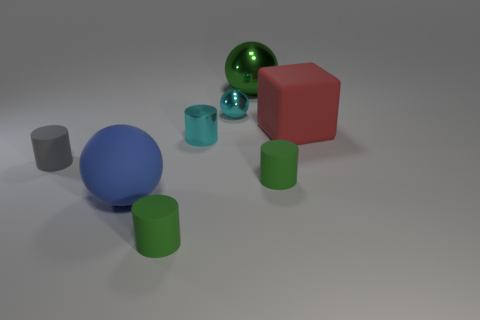What is the size of the metal object that is the same color as the metal cylinder?
Provide a short and direct response. Small. There is a matte cylinder that is to the left of the small thing that is in front of the blue rubber sphere; what color is it?
Make the answer very short. Gray. Are there any things of the same color as the tiny ball?
Give a very brief answer. Yes. What color is the metallic object that is the same size as the cyan shiny ball?
Give a very brief answer. Cyan. Is the small green object in front of the blue rubber thing made of the same material as the large green ball?
Make the answer very short. No. There is a green rubber thing behind the tiny green object that is left of the cyan shiny cylinder; are there any tiny green things that are on the left side of it?
Give a very brief answer. Yes. There is a big green shiny object behind the tiny cyan cylinder; is its shape the same as the red matte thing?
Make the answer very short. No. The matte object that is in front of the sphere in front of the big matte block is what shape?
Your answer should be compact. Cylinder. There is a shiny thing that is right of the tiny cyan object behind the large rubber thing right of the small cyan cylinder; how big is it?
Your answer should be compact. Large. There is another big metal thing that is the same shape as the large blue thing; what color is it?
Give a very brief answer. Green. 